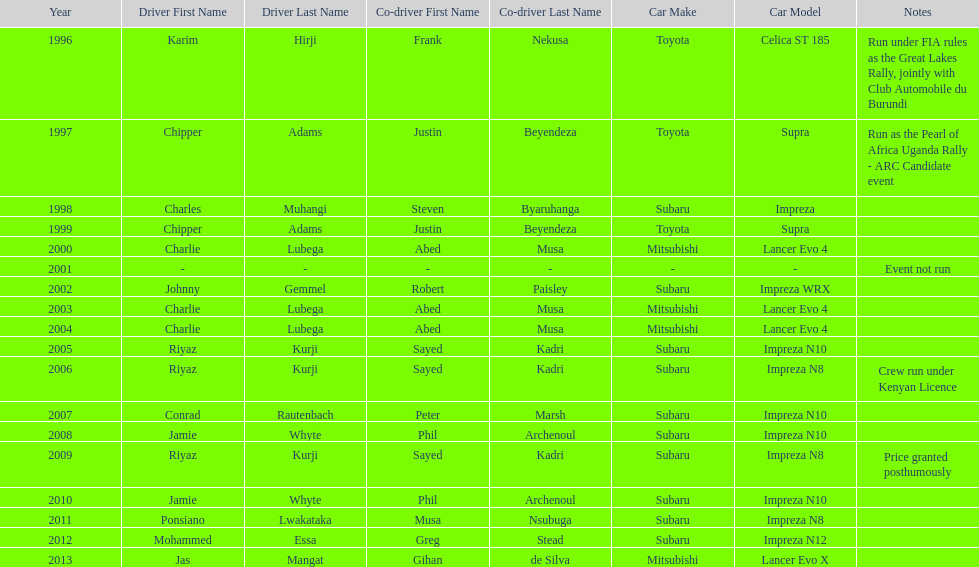Which was the only year that the event was not run? 2001. 